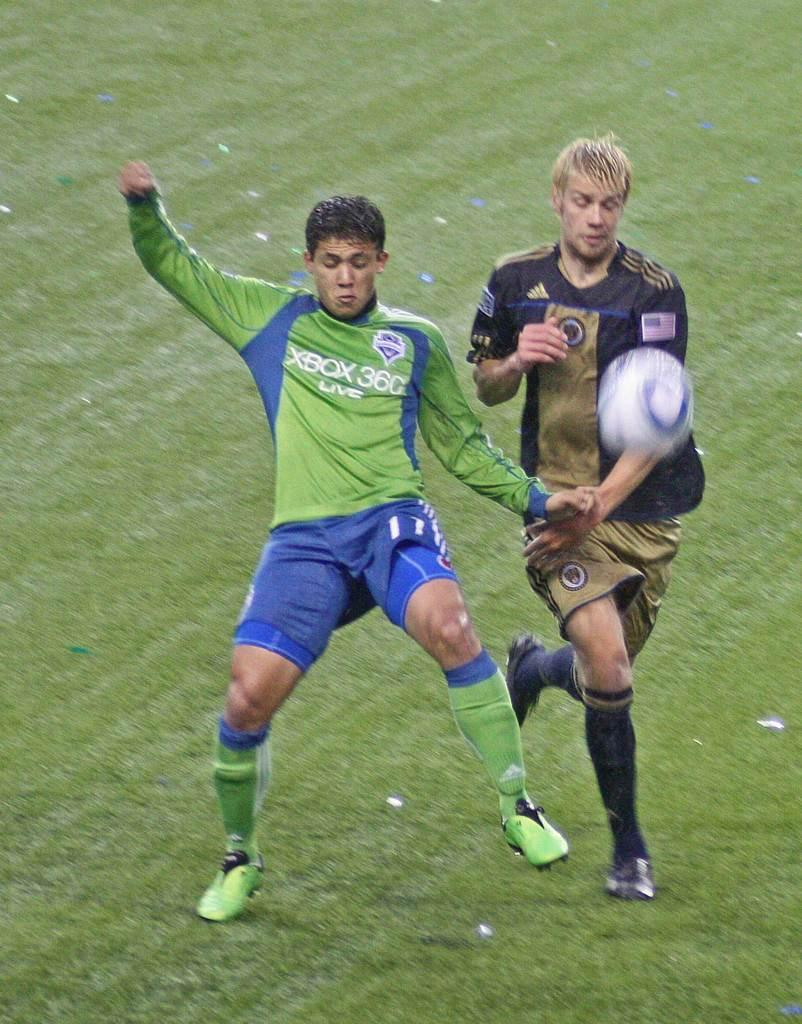How many people are in the image? There are two men in the image. What are the men doing in the image? The men are running on the ground. Is there any object in the air in the image? Yes, there is a ball in the air. What type of wheel can be seen in the image? There is no wheel present in the image. What emotion are the men displaying in the image? The provided facts do not mention the emotions of the men, so it cannot be determined from the image. 